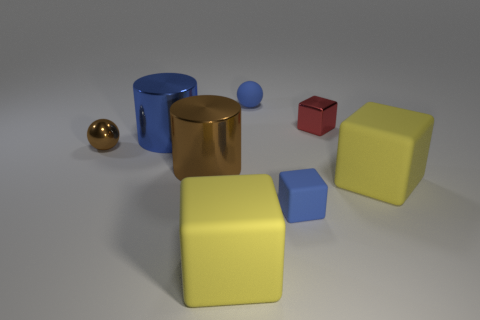There is a thing that is both behind the brown shiny ball and to the right of the blue block; what is its size?
Offer a terse response. Small. There is another small matte thing that is the same shape as the red object; what is its color?
Give a very brief answer. Blue. What color is the large rubber object on the left side of the sphere behind the red cube?
Your answer should be very brief. Yellow. The small brown shiny thing is what shape?
Your answer should be very brief. Sphere. The metal thing that is on the right side of the big blue shiny cylinder and in front of the big blue shiny cylinder has what shape?
Provide a succinct answer. Cylinder. The small thing that is made of the same material as the blue ball is what color?
Offer a very short reply. Blue. What shape is the tiny object behind the red block on the left side of the big object that is right of the red shiny object?
Keep it short and to the point. Sphere. How big is the blue block?
Offer a very short reply. Small. There is a small blue object that is made of the same material as the small blue cube; what is its shape?
Provide a short and direct response. Sphere. Are there fewer large matte blocks behind the brown metallic ball than big yellow matte things?
Provide a short and direct response. Yes. 